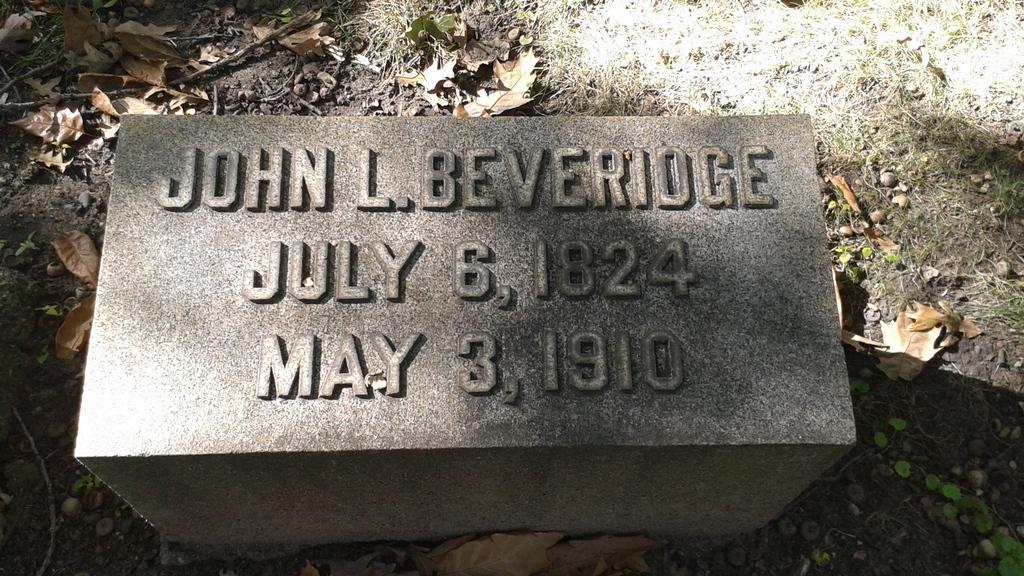How would you summarize this image in a sentence or two? In this image there is a headstone with name, date of birth and date of death engraved on it, around the stone there are dry leaves and stones on the surface. 